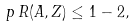Convert formula to latex. <formula><loc_0><loc_0><loc_500><loc_500>p \, R ( A , Z ) \leq 1 - 2 ,</formula> 